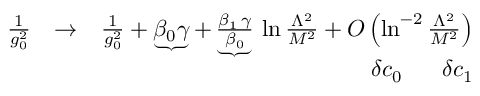<formula> <loc_0><loc_0><loc_500><loc_500>\begin{array} { r l r } { { \frac { 1 } { g _ { 0 } ^ { 2 } } } } & { \to } & { { \frac { 1 } { g _ { 0 } ^ { 2 } } } + \underbrace { \beta _ { 0 } \gamma } + \underbrace { \frac { \beta _ { 1 } \, \gamma } { \beta _ { 0 } } } \, \ln { \frac { \Lambda ^ { 2 } } { M ^ { 2 } } } + O \left ( \ln ^ { - 2 } { \frac { \Lambda ^ { 2 } } { M ^ { 2 } } } \right ) } \\ & { \quad d e l t a c _ { 0 } \quad d e l t a c _ { 1 } } \end{array}</formula> 